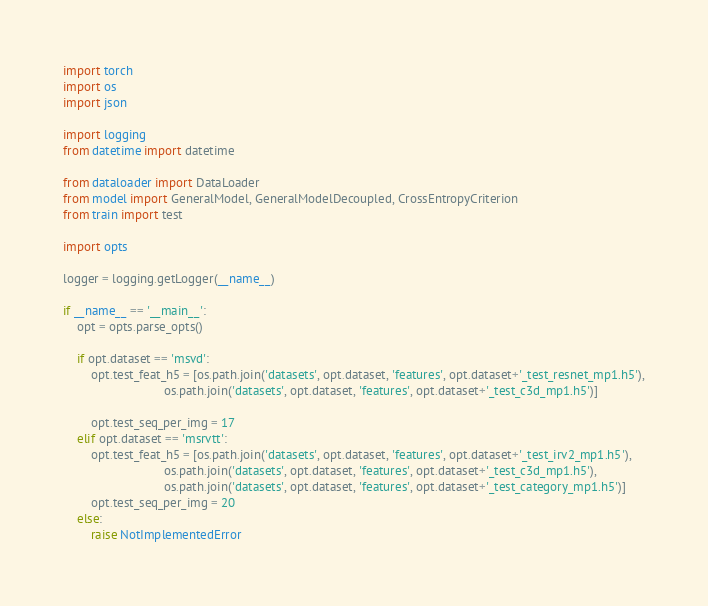<code> <loc_0><loc_0><loc_500><loc_500><_Python_>import torch
import os
import json

import logging
from datetime import datetime

from dataloader import DataLoader
from model import GeneralModel, GeneralModelDecoupled, CrossEntropyCriterion
from train import test

import opts

logger = logging.getLogger(__name__)

if __name__ == '__main__':
    opt = opts.parse_opts()

    if opt.dataset == 'msvd':
        opt.test_feat_h5 = [os.path.join('datasets', opt.dataset, 'features', opt.dataset+'_test_resnet_mp1.h5'),
                             os.path.join('datasets', opt.dataset, 'features', opt.dataset+'_test_c3d_mp1.h5')]

        opt.test_seq_per_img = 17
    elif opt.dataset == 'msrvtt':
        opt.test_feat_h5 = [os.path.join('datasets', opt.dataset, 'features', opt.dataset+'_test_irv2_mp1.h5'),
                             os.path.join('datasets', opt.dataset, 'features', opt.dataset+'_test_c3d_mp1.h5'),
                             os.path.join('datasets', opt.dataset, 'features', opt.dataset+'_test_category_mp1.h5')]
        opt.test_seq_per_img = 20
    else:
        raise NotImplementedError
</code> 